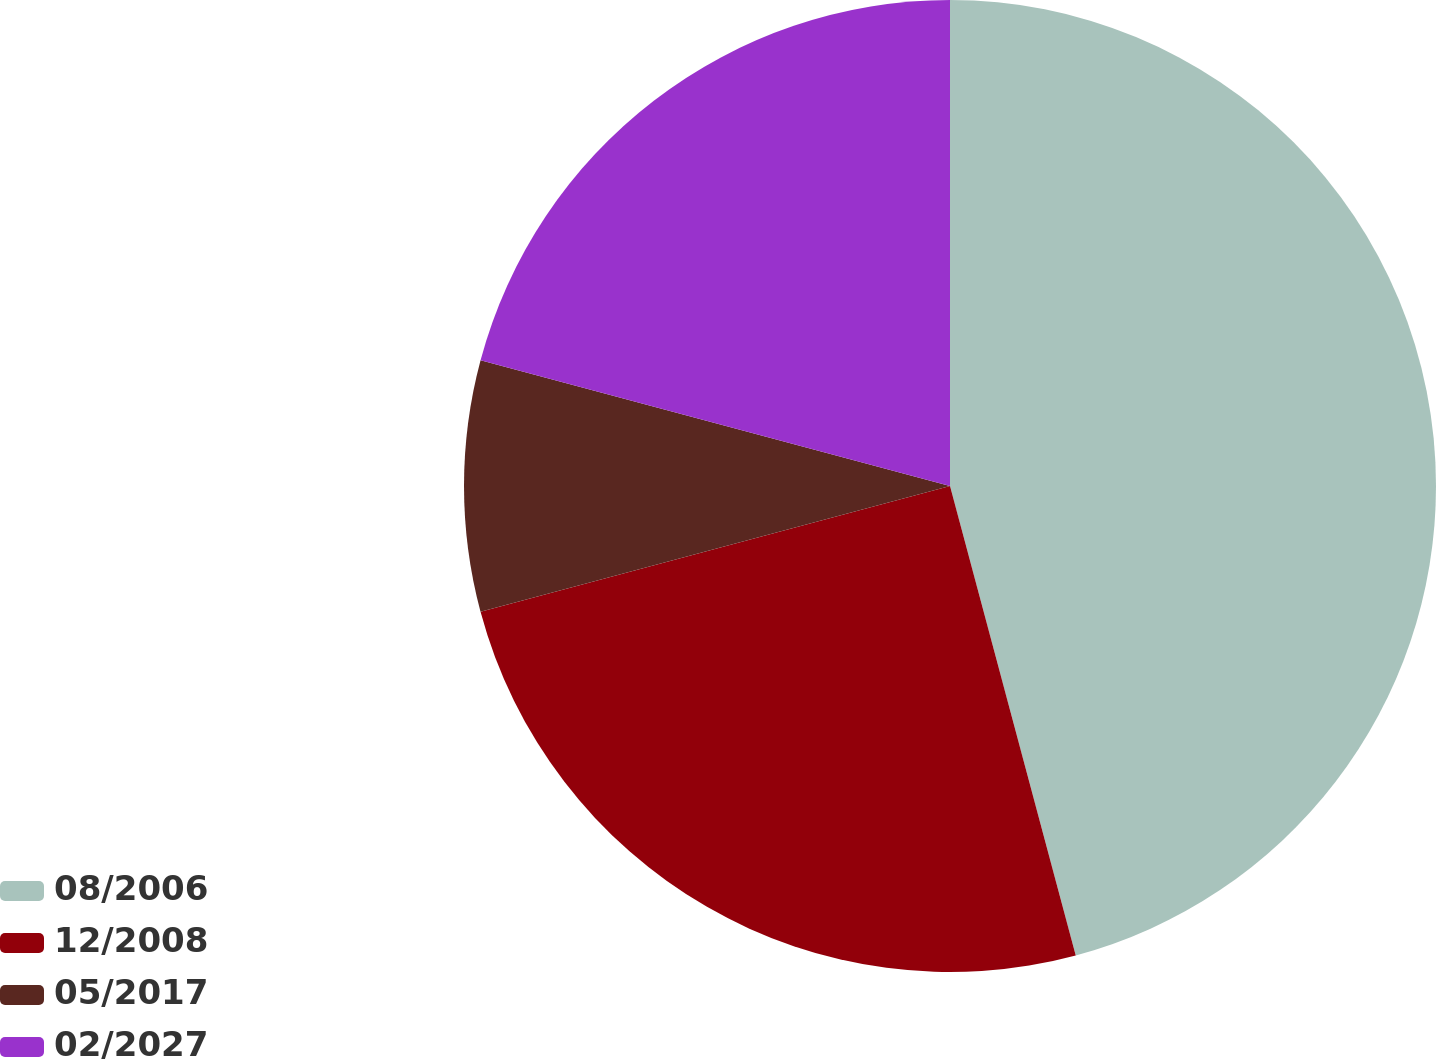Convert chart. <chart><loc_0><loc_0><loc_500><loc_500><pie_chart><fcel>08/2006<fcel>12/2008<fcel>05/2017<fcel>02/2027<nl><fcel>45.83%<fcel>25.0%<fcel>8.33%<fcel>20.83%<nl></chart> 